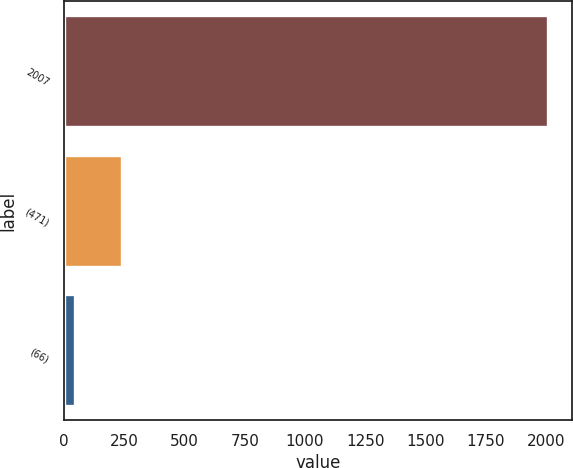<chart> <loc_0><loc_0><loc_500><loc_500><bar_chart><fcel>2007<fcel>(471)<fcel>(66)<nl><fcel>2005<fcel>241<fcel>45<nl></chart> 